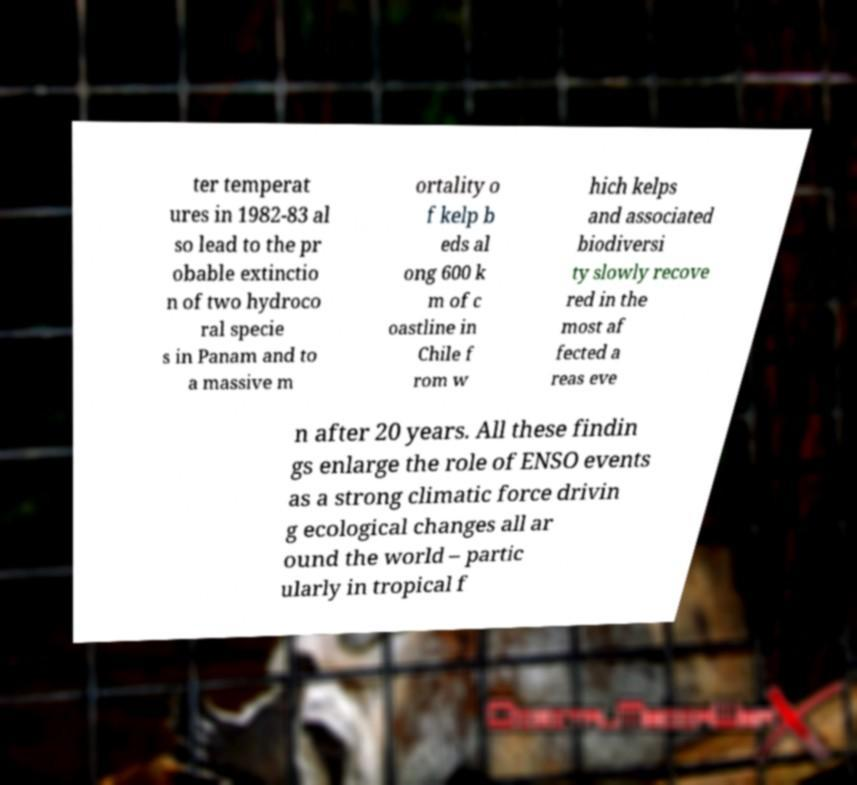For documentation purposes, I need the text within this image transcribed. Could you provide that? ter temperat ures in 1982-83 al so lead to the pr obable extinctio n of two hydroco ral specie s in Panam and to a massive m ortality o f kelp b eds al ong 600 k m of c oastline in Chile f rom w hich kelps and associated biodiversi ty slowly recove red in the most af fected a reas eve n after 20 years. All these findin gs enlarge the role of ENSO events as a strong climatic force drivin g ecological changes all ar ound the world – partic ularly in tropical f 